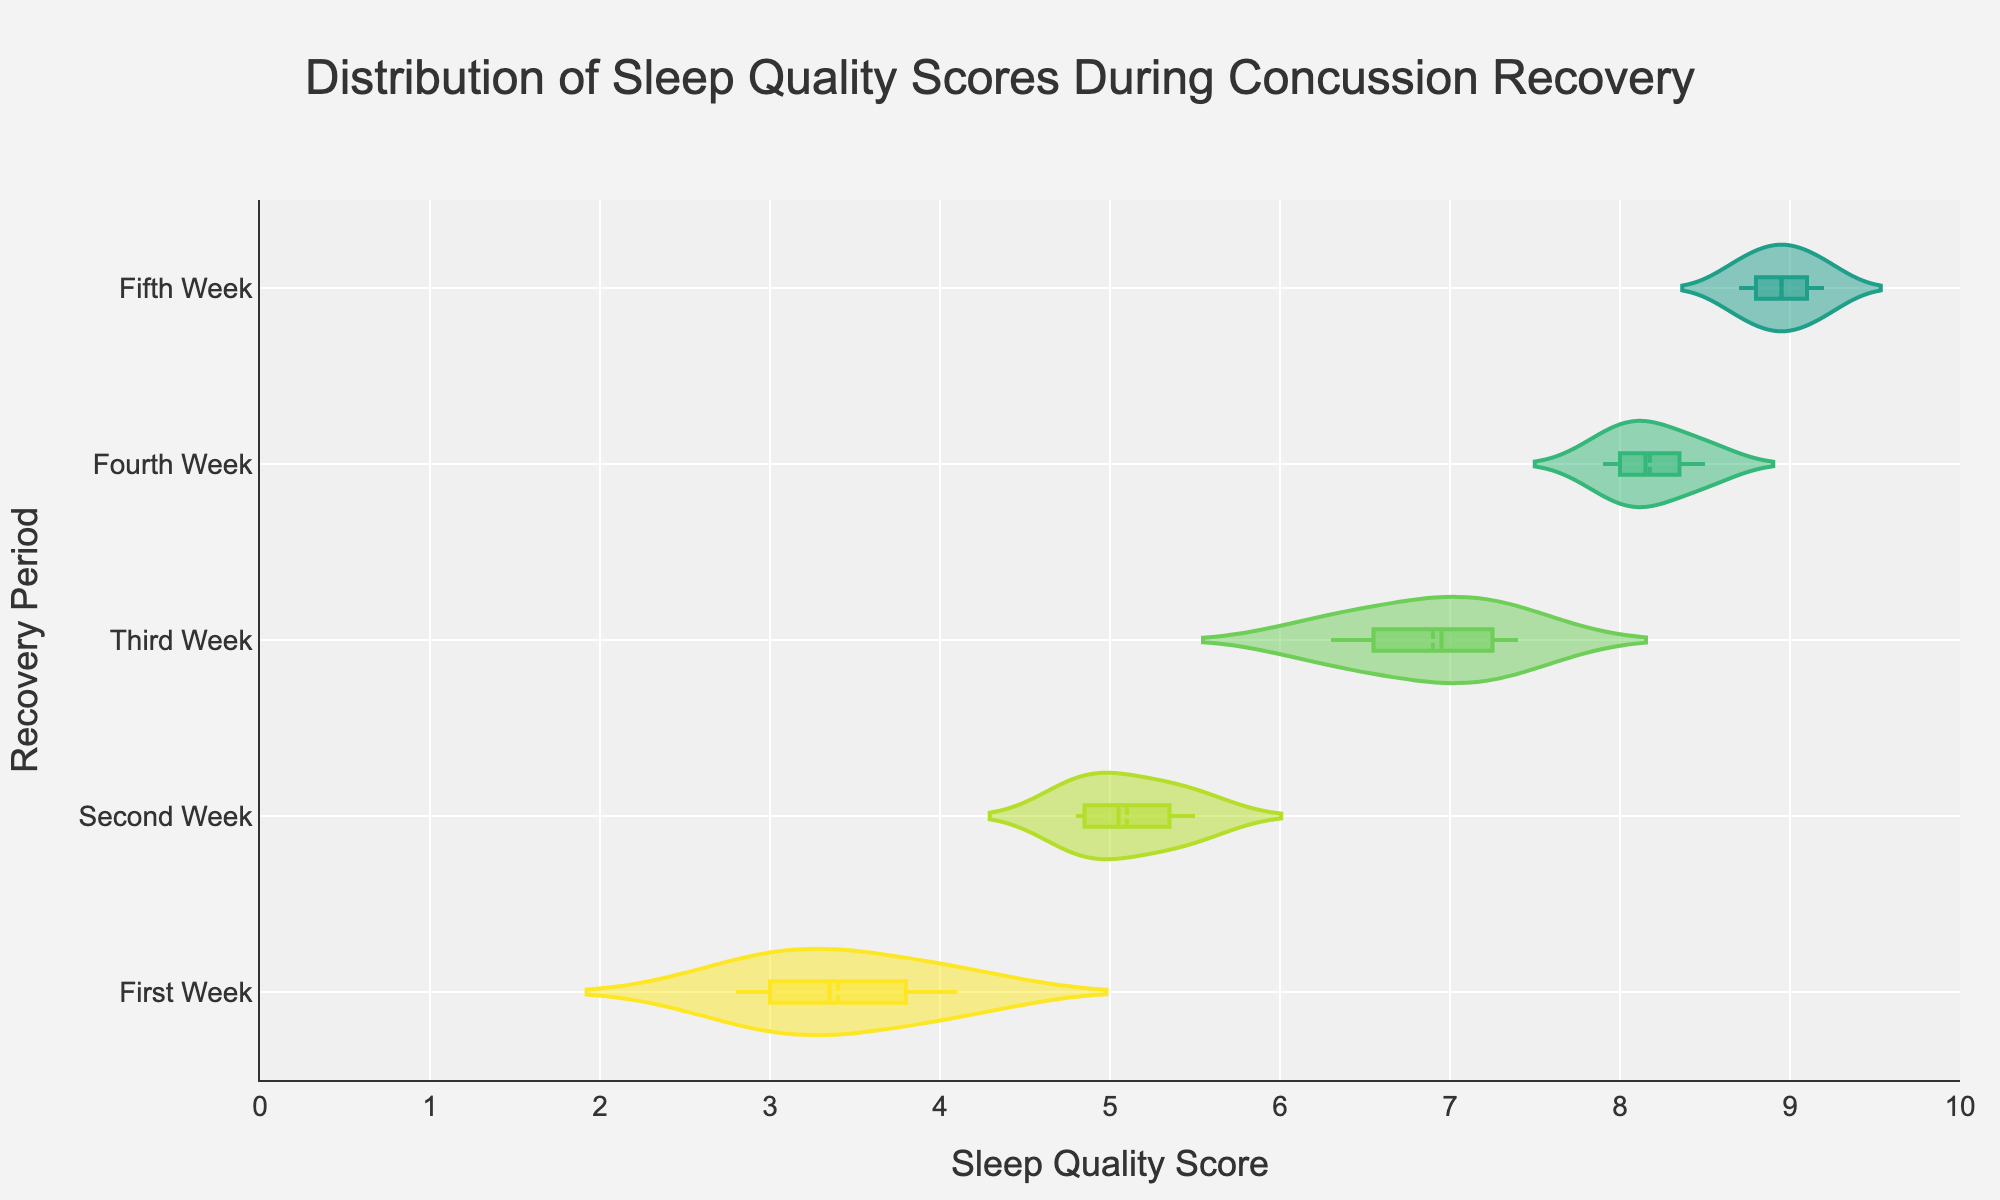What is the title of the plot? The title is usually at the top of the plot and provides a description of what the plot represents.
Answer: Distribution of Sleep Quality Scores During Concussion Recovery What does the x-axis represent? The x-axis typically represents the variable being measured or observed. In this plot, it is labeled and shows the range of sleep quality scores.
Answer: Sleep Quality Score Which recovery period shows the highest sleep quality scores? By looking at the position of the highest points on the x-axis and their corresponding categories, you can find the period with the highest scores.
Answer: Fifth Week How does sleep quality change from the First Week to the Fifth Week? Observing the distribution across weeks, you can see if the scores increase or decrease over time. Sleep quality scores appear to improve progressively each week.
Answer: It improves What is the range of sleep quality scores in the Second Week? Check the distance covered by the Second Week distribution on the x-axis.
Answer: 4.8 to 5.5 Which recovery period has the most variability in sleep quality scores? Identify the week with the wide spread of values along the x-axis. Usually, a wider range indicates more variability.
Answer: Third Week Which week shows the least variability in sleep quality scores? Look for the week with the narrowest range of values along the x-axis.
Answer: First Week During which week does sleep quality score have the highest median value? Observe the position of the median line within each week’s distribution.
Answer: Fifth Week How does the sleep quality score distribution in the Fourth Week compare to that in the Third Week? Compare the spread and center of the distributions for these two weeks to see which one is higher or more variable.
Answer: Fourth Week's scores are generally higher and less variable than Third Week's What is the median sleep quality score in the First Week? Look at the median line in the First Week’s distribution for the value.
Answer: 3.5 